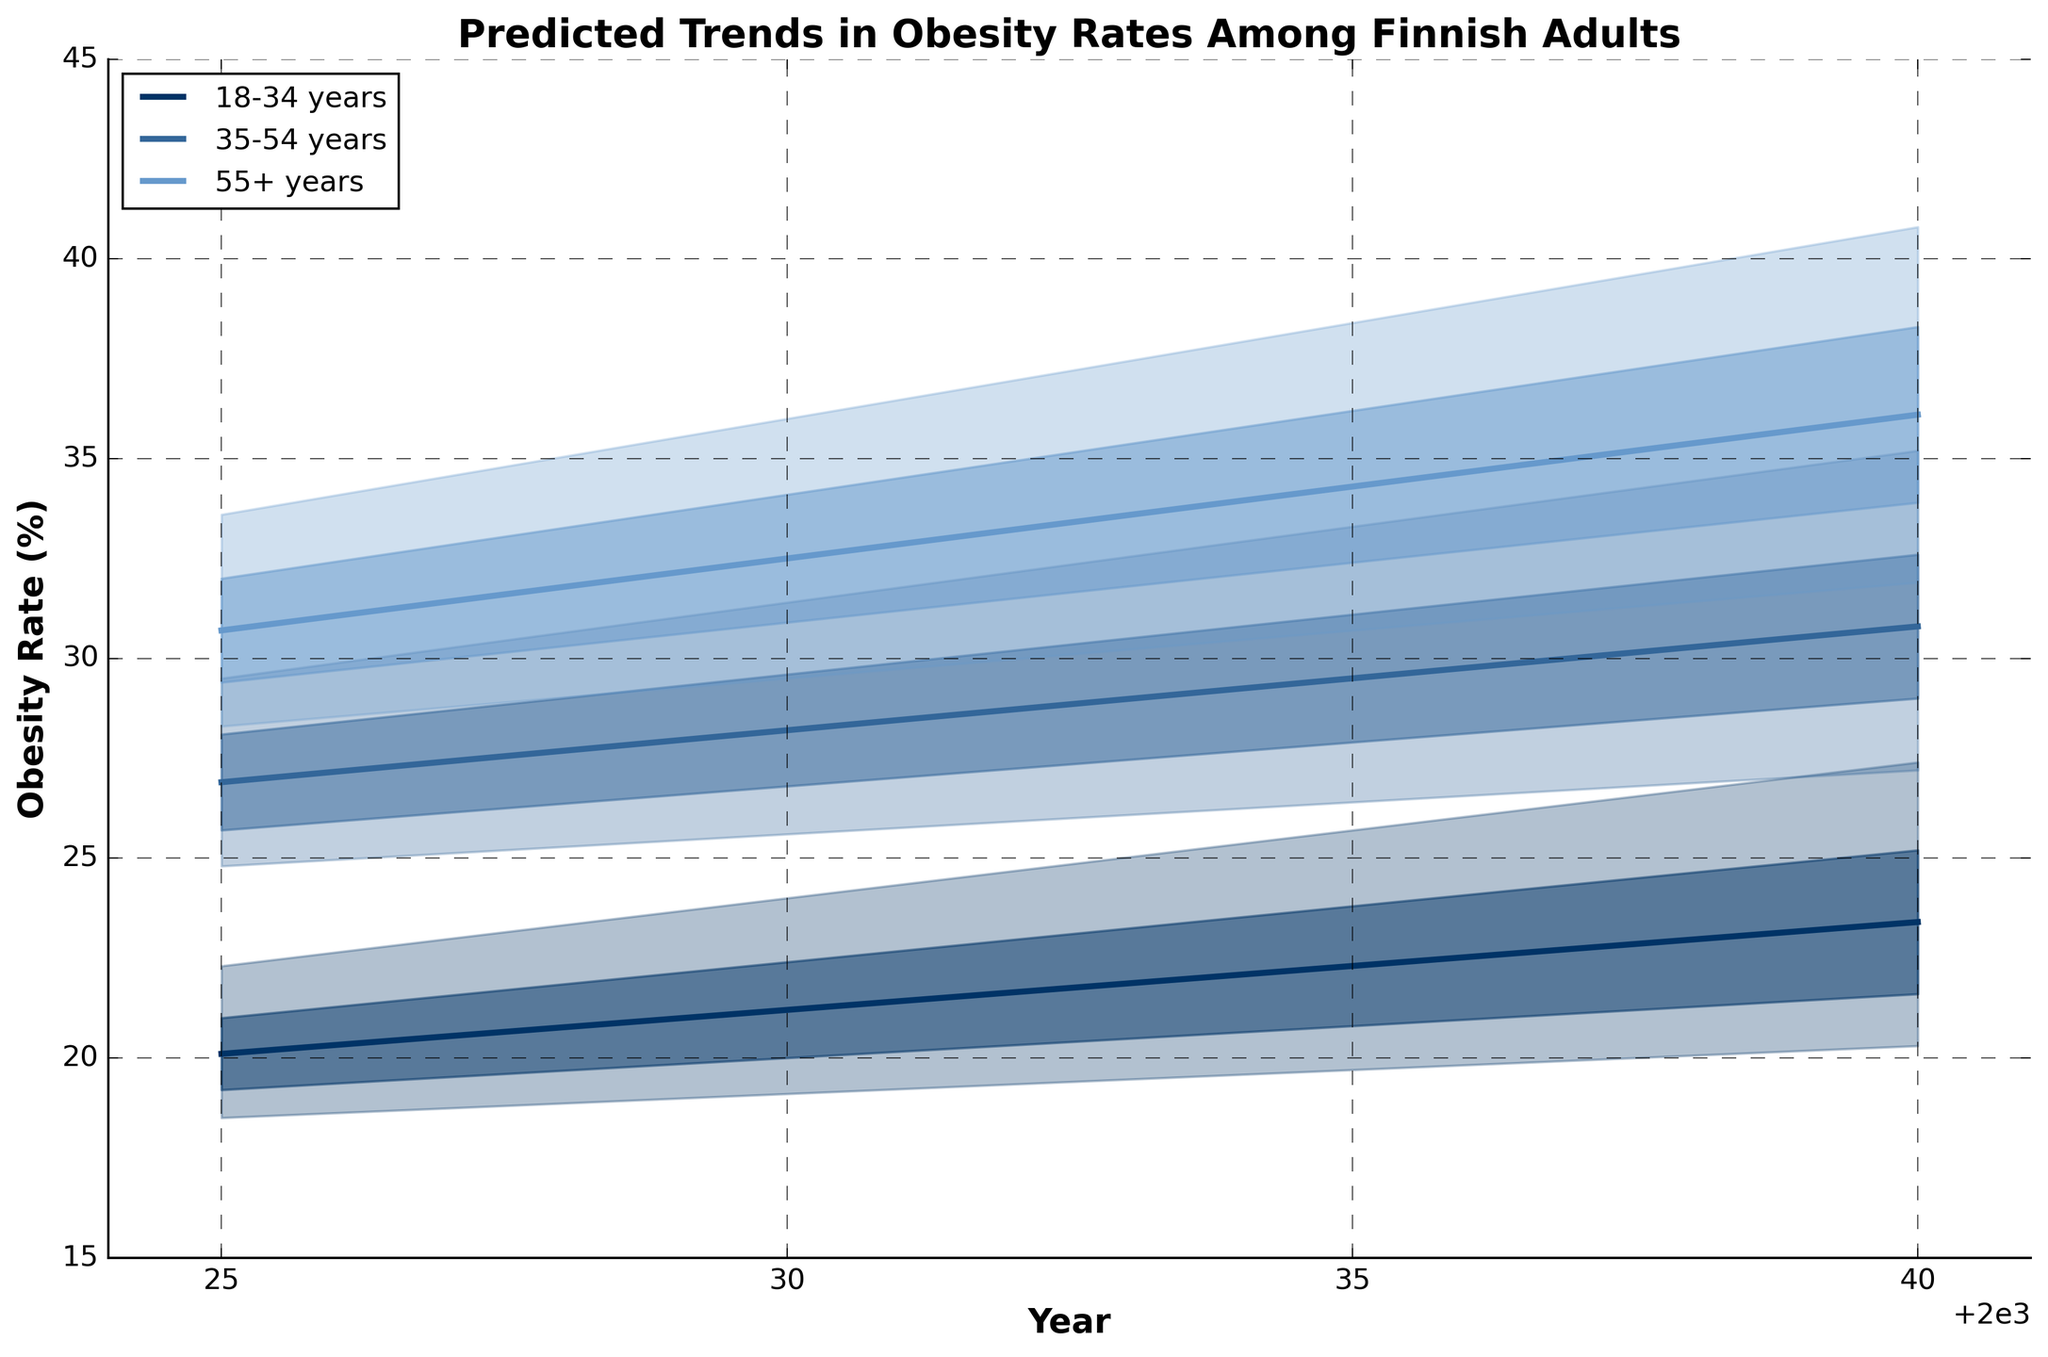What are the predicted obesity rates for Finnish adults aged 55+ in 2040? According to the data, the estimated obesity rates for Finnish adults aged 55+ in 2040 are between 31.9% (Low Estimate) and 40.8% (High Estimate). This range represents the uncertainty in the prediction.
Answer: Between 31.9% and 40.8% Which age group is predicted to have the highest obesity rate in 2035? By examining the mid-estimate values for 2035, the age group 55+ has the highest predicted obesity rate at 34.3%.
Answer: 55+ How do the predicted obesity rates for adults aged 18-34 change from 2025 to 2040? Looking at the mid-estimates for 18-34 years, the obesity rate increases from 20.1% in 2025 to 23.4% in 2040. The step-by-step change in values can be seen as follows: 2025: 20.1%, 2030: 21.2%, 2035: 22.3%, and 2040: 23.4%.
Answer: Increase from 20.1% to 23.4% For the year 2030, which age group has the narrowest range of predicted obesity rates? The ranges of predicted obesity rates for 2030 can be calculated by subtracting the low estimate from the high estimate for each age group. The narrowest range is for the 18-34 age group, which is 24.0% - 19.1% = 4.9%.
Answer: 18-34 What is the predicted obesity rate trend for adults aged 35-54 over the next 20 years? The mid-estimates for adults aged 35-54 are as follows: 26.9% in 2025, 28.2% in 2030, 29.5% in 2035, and 30.8% in 2040. The trend shows a steady increase over the next 20 years.
Answer: Increasing Comparing the year 2025, which age group has the highest low estimate of obesity rate, and by how much? In 2025, the low estimates for the age groups are: 18-34: 18.5%, 35-54: 24.8%, 55+: 28.3%. The highest low estimate is for the 55+ age group at 28.3%, which is 3.5% higher than the next highest group (35-54).
Answer: 55+, 3.5% By what percentage does the mid-estimate obesity rate for adults aged 35-54 increase from 2025 to 2040? The mid-estimate obesity rates for adults aged 35-54 are 26.9% in 2025 and 30.8% in 2040. The percentage increase is calculated as ((30.8 - 26.9) / 26.9) * 100 = 14.5%.
Answer: 14.5% Among all age groups, which group shows the highest variation in predicted obesity rates in 2040? The variation is represented by the difference between the low and high estimates. For 2040, the variations are: 18-34: 27.4% - 20.3% = 7.1%, 35-54: 35.2% - 27.2% = 8%, 55+: 40.8% - 31.9% = 8.9%. The highest variation is in the 55+ age group at 8.9%.
Answer: 55+ 